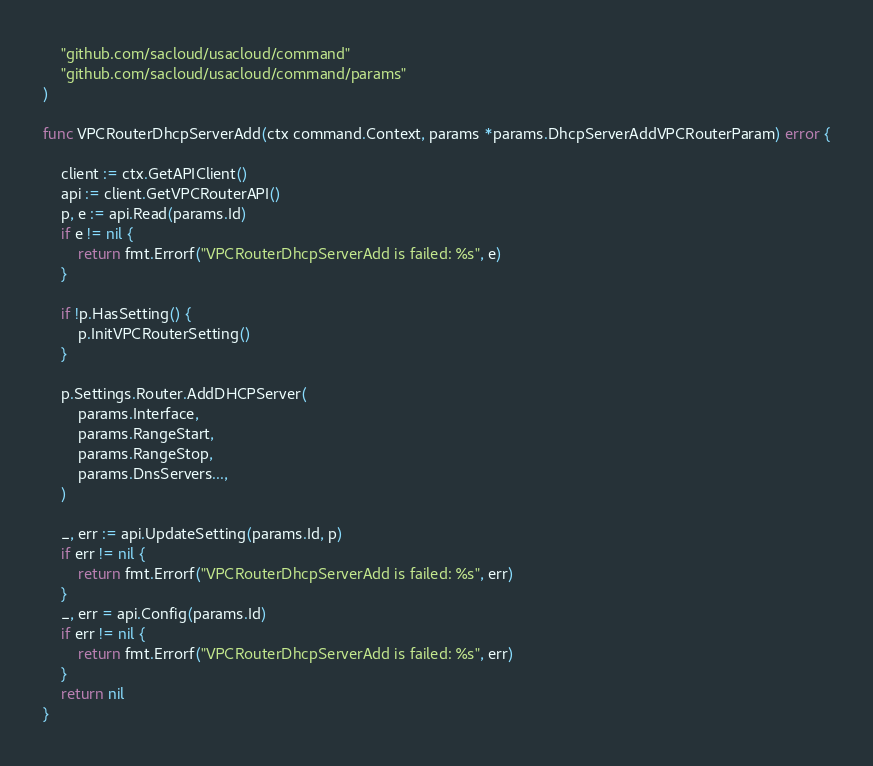Convert code to text. <code><loc_0><loc_0><loc_500><loc_500><_Go_>
	"github.com/sacloud/usacloud/command"
	"github.com/sacloud/usacloud/command/params"
)

func VPCRouterDhcpServerAdd(ctx command.Context, params *params.DhcpServerAddVPCRouterParam) error {

	client := ctx.GetAPIClient()
	api := client.GetVPCRouterAPI()
	p, e := api.Read(params.Id)
	if e != nil {
		return fmt.Errorf("VPCRouterDhcpServerAdd is failed: %s", e)
	}

	if !p.HasSetting() {
		p.InitVPCRouterSetting()
	}

	p.Settings.Router.AddDHCPServer(
		params.Interface,
		params.RangeStart,
		params.RangeStop,
		params.DnsServers...,
	)

	_, err := api.UpdateSetting(params.Id, p)
	if err != nil {
		return fmt.Errorf("VPCRouterDhcpServerAdd is failed: %s", err)
	}
	_, err = api.Config(params.Id)
	if err != nil {
		return fmt.Errorf("VPCRouterDhcpServerAdd is failed: %s", err)
	}
	return nil
}
</code> 